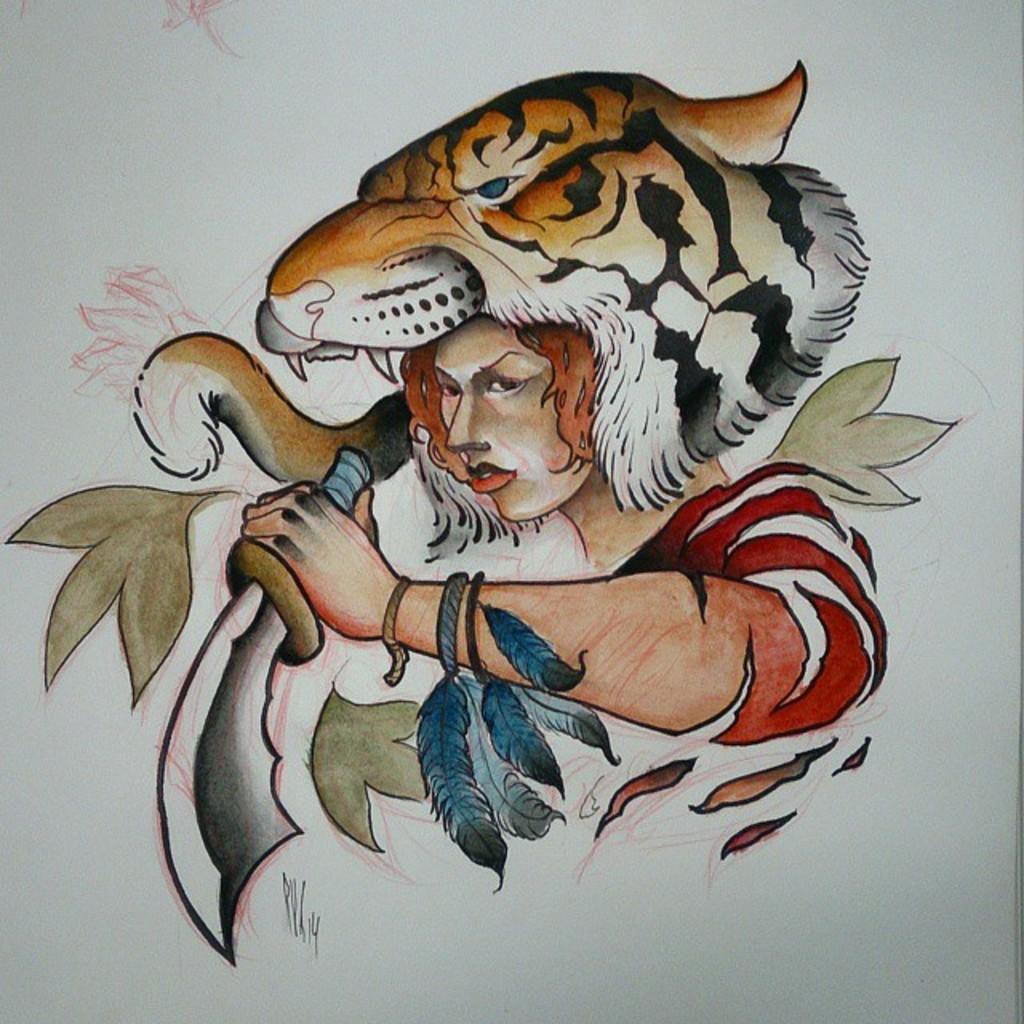What is the main subject of the image? There is a painting in the image. What is depicted in the painting? The painting depicts a person. What is the person holding in the painting? The person is holding a sword. What type of notebook is the person using to push their vein in the image? There is no notebook or vein-pushing activity present in the image; it features a painting of a person holding a sword. 